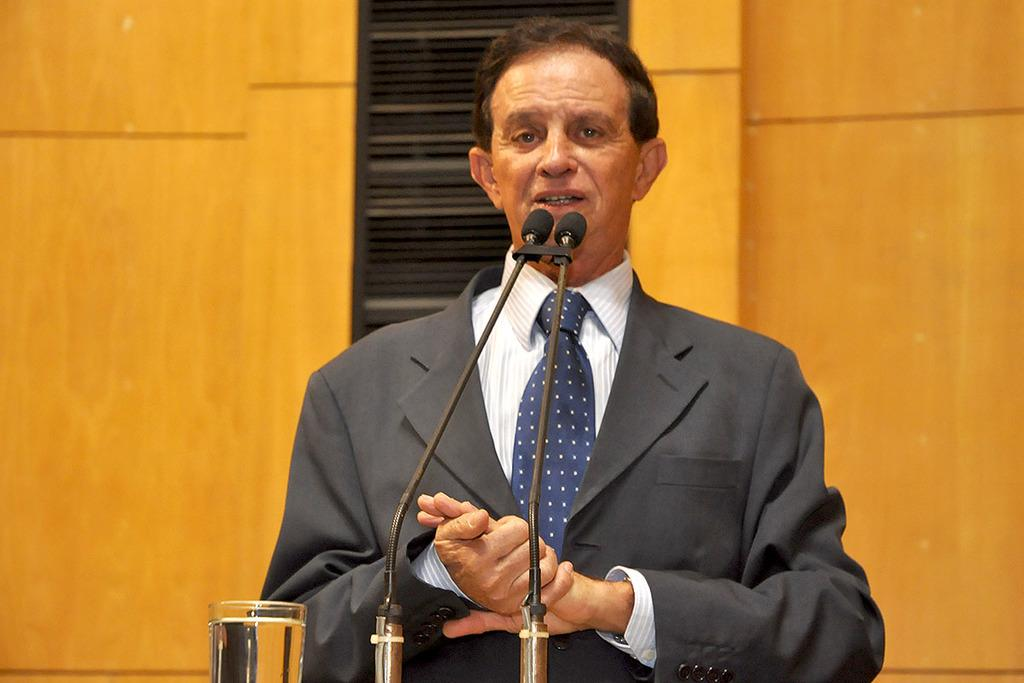Who is the person in the image? There is a man in the image. What is the man wearing? The man is wearing a suit. What is the man doing in the image? The man is talking in front of microphones. What can be seen in the image besides the man and the microphones? There is a glass with water in the image. What is visible in the background of the image? There is a wall in the background of the image. What type of finger can be seen holding a twig in the image? There is no finger or twig present in the image. 